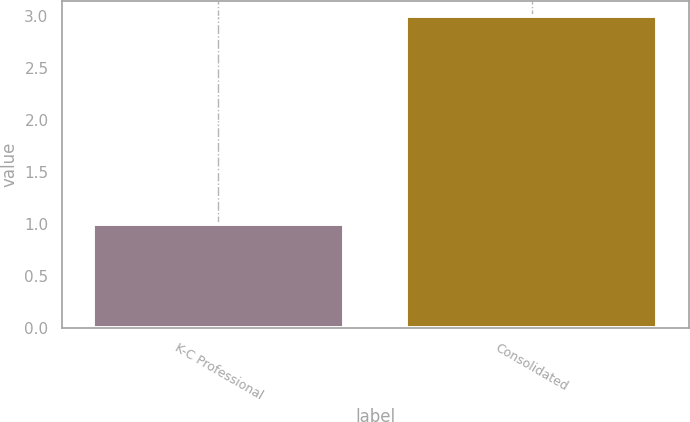<chart> <loc_0><loc_0><loc_500><loc_500><bar_chart><fcel>K-C Professional<fcel>Consolidated<nl><fcel>1<fcel>3<nl></chart> 